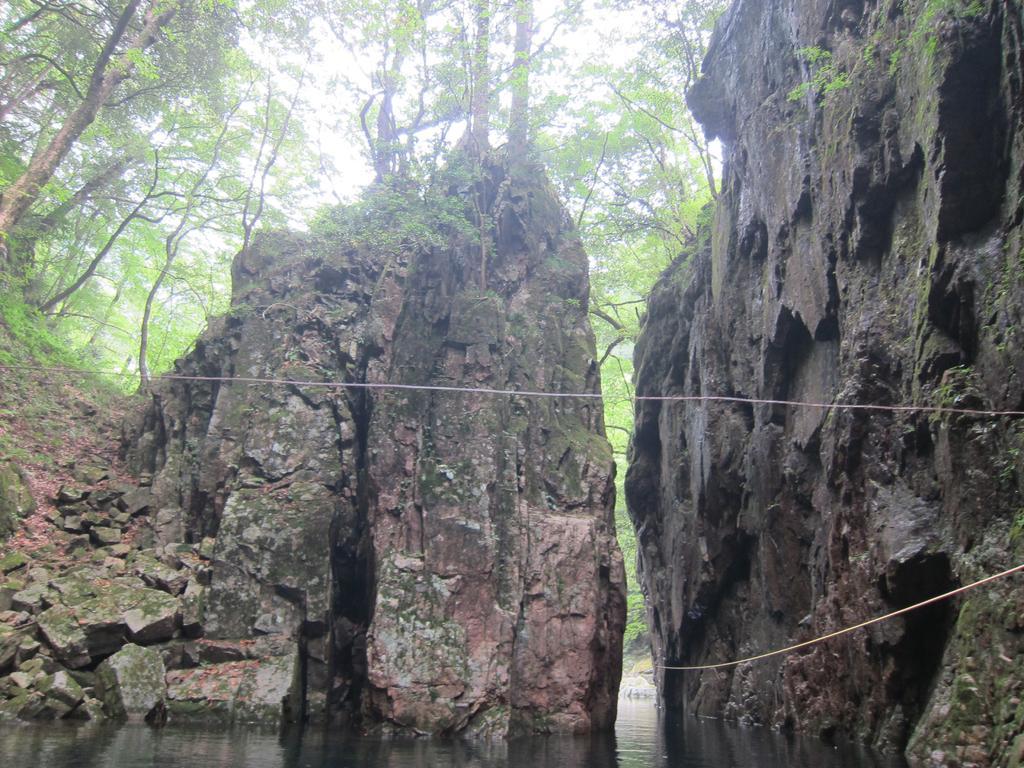Could you give a brief overview of what you see in this image? In the image we can see there are stones, big rock, water, grass and a sky. 